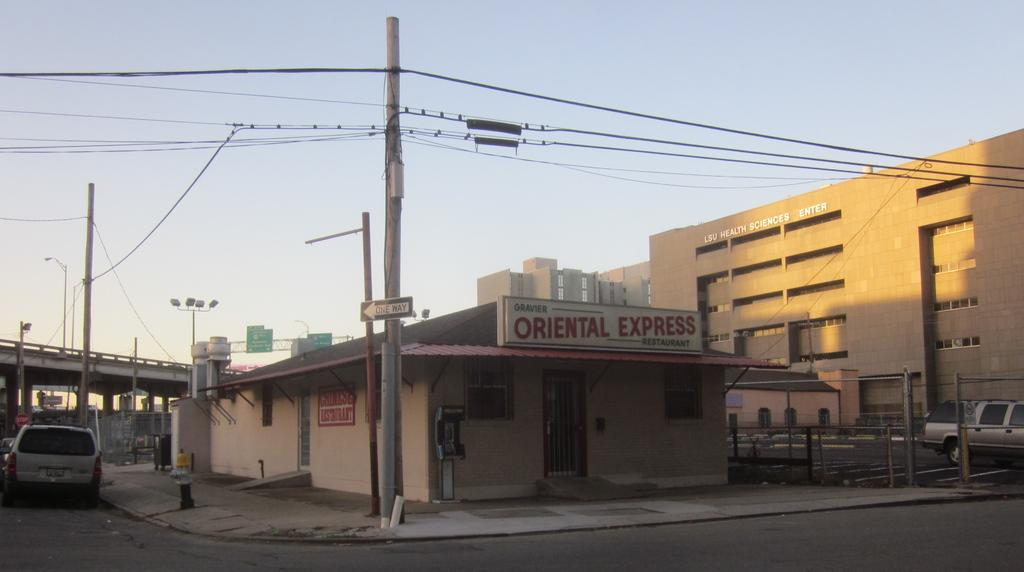What type of structures can be seen in the image? There are buildings in the image. What other objects can be seen in the image? There are poles, cars, and boards visible in the image. What is present at the top of the image? Wires and the sky are visible at the top of the image. Where is the bridge located in the image? The bridge is on the left side of the image. What is the purpose of the poles in the image? The purpose of the poles is not explicitly stated, but they may be used for supporting wires or other infrastructure. How many oranges are being held by the feet of the people in the image? There are no people or oranges present in the image. What type of humor is being displayed by the boards in the image? There is no humor displayed by the boards in the image; they are simply objects in the scene. 